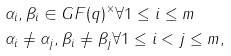<formula> <loc_0><loc_0><loc_500><loc_500>& \alpha _ { i } , \beta _ { i } \in G F ( q ) ^ { \times } \forall 1 \leq i \leq m \\ & \alpha _ { i } \neq \alpha _ { j } , \beta _ { i } \neq \beta _ { j } \forall 1 \leq i < j \leq m ,</formula> 